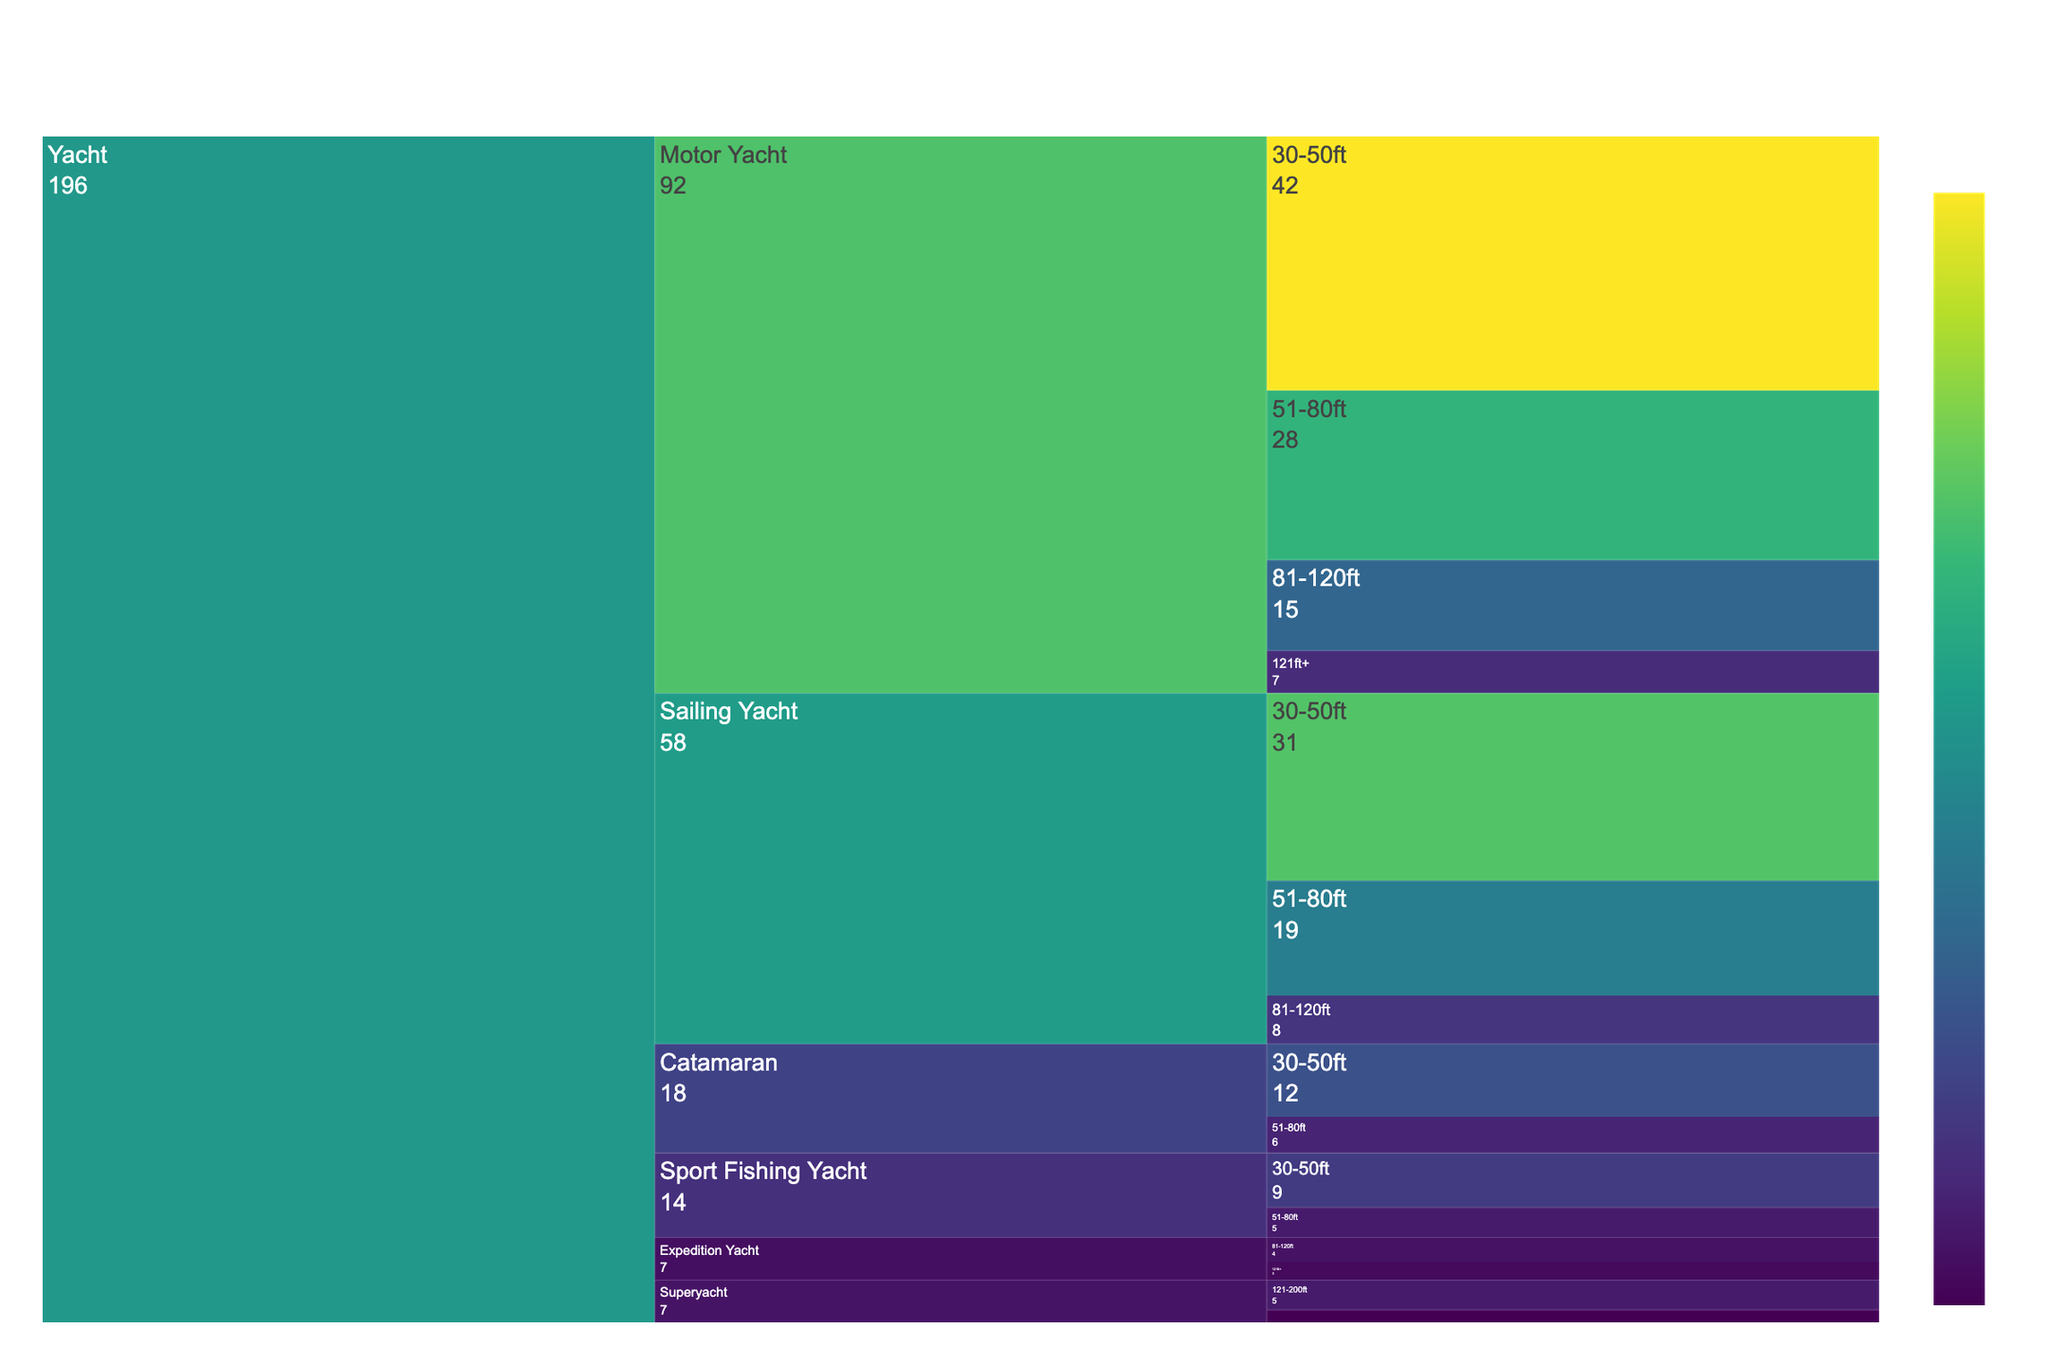How many yachts docked at the marina are under the category 'Motor Yacht'? There are 'Count' values for each size under 'Motor Yacht': 42 for 30-50ft, 28 for 51-80ft, 15 for 81-120ft, and 7 for 121ft+. Summing these up results in 42 + 28 + 15 + 7 = 92.
Answer: 92 Which yacht type has the highest count in the 'Superyacht' category? Under the 'Superyacht' category, the 'Count' values are 5 for 121-200ft and 2 for 201ft+. The highest count is 5 for 121-200ft.
Answer: 121-200ft Compare the counts of 'Sport Fishing Yacht' in the size ranges 30-50ft and 51-80ft. Which size range is more frequent? The counts for 'Sport Fishing Yacht' are 9 for 30-50ft and 5 for 51-80ft. Comparing these two, 9 (30-50ft) is greater than 5 (51-80ft).
Answer: 30-50ft Which size range under 'Sailing Yacht' has the lowest count? For 'Sailing Yacht': the counts are 31 for 30-50ft, 19 for 51-80ft, and 8 for 81-120ft. The lowest count is 8 (81-120ft).
Answer: 81-120ft What is the total number of yachts docked at the marina in the past year? Summing all the 'Count' values for each yacht size and type: 42 + 28 + 15 + 7 + 31 + 19 + 8 + 12 + 6 + 5 + 2 + 4 + 3 + 9 + 5 = 196.
Answer: 196 Is the count of 'Catamarans' more or less than half the count of 'Motor Yachts'? The total count for 'Catamaran' is 12 + 6 = 18. Half of the count for 'Motor Yacht' is 92 / 2 = 46. Comparing these values, 18 is less than 46.
Answer: Less How does the count of 'Expedition Yacht' of 81-120ft compare to the count of 'Superyacht' of 121-200ft? The count for 'Expedition Yacht' of 81-120ft is 4, while the count for 'Superyacht' of 121-200ft is 5. Comparing, 4 < 5.
Answer: Less Which is the most frequent size range overall across all yacht types? Sum the counts for each size range: 30-50ft: 42 + 31 + 12 + 9 = 94, 51-80ft: 28 + 19 + 6 + 5 = 58, 81-120ft: 15 + 8 + 4 = 27, 121ft+: 7 + 3 = 10, Superyacht: 5 + 2 = 7. The most frequent size range is 30-50ft with 94.
Answer: 30-50ft 